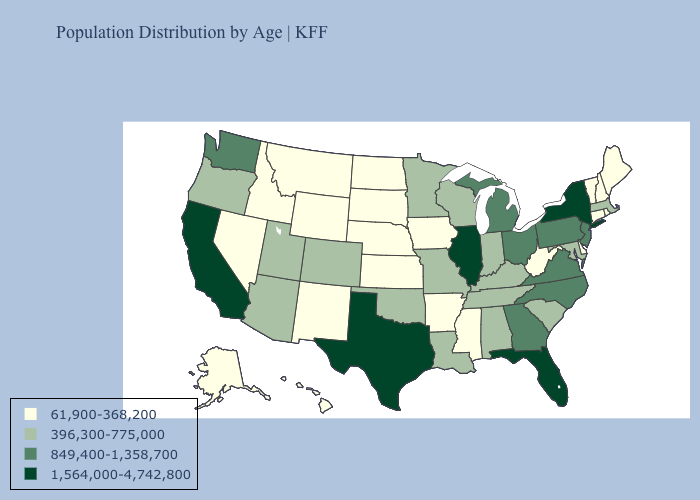What is the value of Illinois?
Be succinct. 1,564,000-4,742,800. What is the highest value in states that border Texas?
Keep it brief. 396,300-775,000. Name the states that have a value in the range 1,564,000-4,742,800?
Keep it brief. California, Florida, Illinois, New York, Texas. Does the map have missing data?
Concise answer only. No. Which states have the lowest value in the USA?
Keep it brief. Alaska, Arkansas, Connecticut, Delaware, Hawaii, Idaho, Iowa, Kansas, Maine, Mississippi, Montana, Nebraska, Nevada, New Hampshire, New Mexico, North Dakota, Rhode Island, South Dakota, Vermont, West Virginia, Wyoming. What is the value of Arizona?
Concise answer only. 396,300-775,000. Does Florida have the highest value in the USA?
Quick response, please. Yes. Does Illinois have the same value as South Carolina?
Keep it brief. No. Name the states that have a value in the range 849,400-1,358,700?
Short answer required. Georgia, Michigan, New Jersey, North Carolina, Ohio, Pennsylvania, Virginia, Washington. What is the value of North Dakota?
Concise answer only. 61,900-368,200. Among the states that border Missouri , which have the highest value?
Concise answer only. Illinois. Name the states that have a value in the range 1,564,000-4,742,800?
Short answer required. California, Florida, Illinois, New York, Texas. Among the states that border West Virginia , does Ohio have the lowest value?
Concise answer only. No. Name the states that have a value in the range 1,564,000-4,742,800?
Write a very short answer. California, Florida, Illinois, New York, Texas. What is the value of Virginia?
Concise answer only. 849,400-1,358,700. 